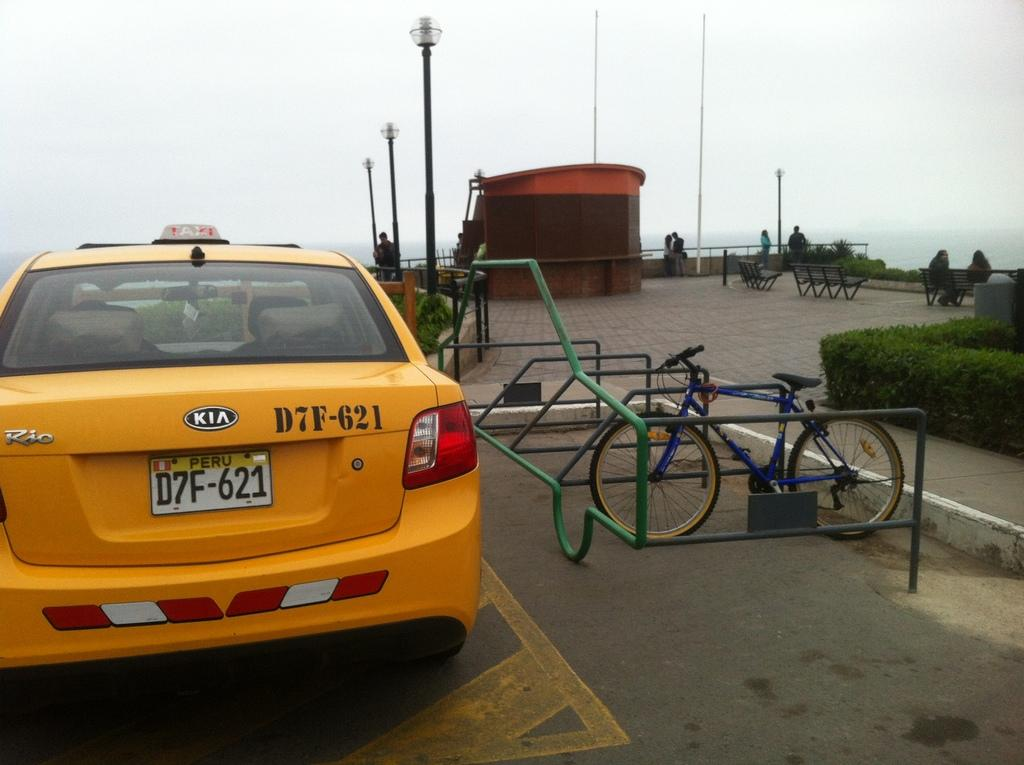<image>
Summarize the visual content of the image. A yellow car is parked near a beach and says Taxi on top. 